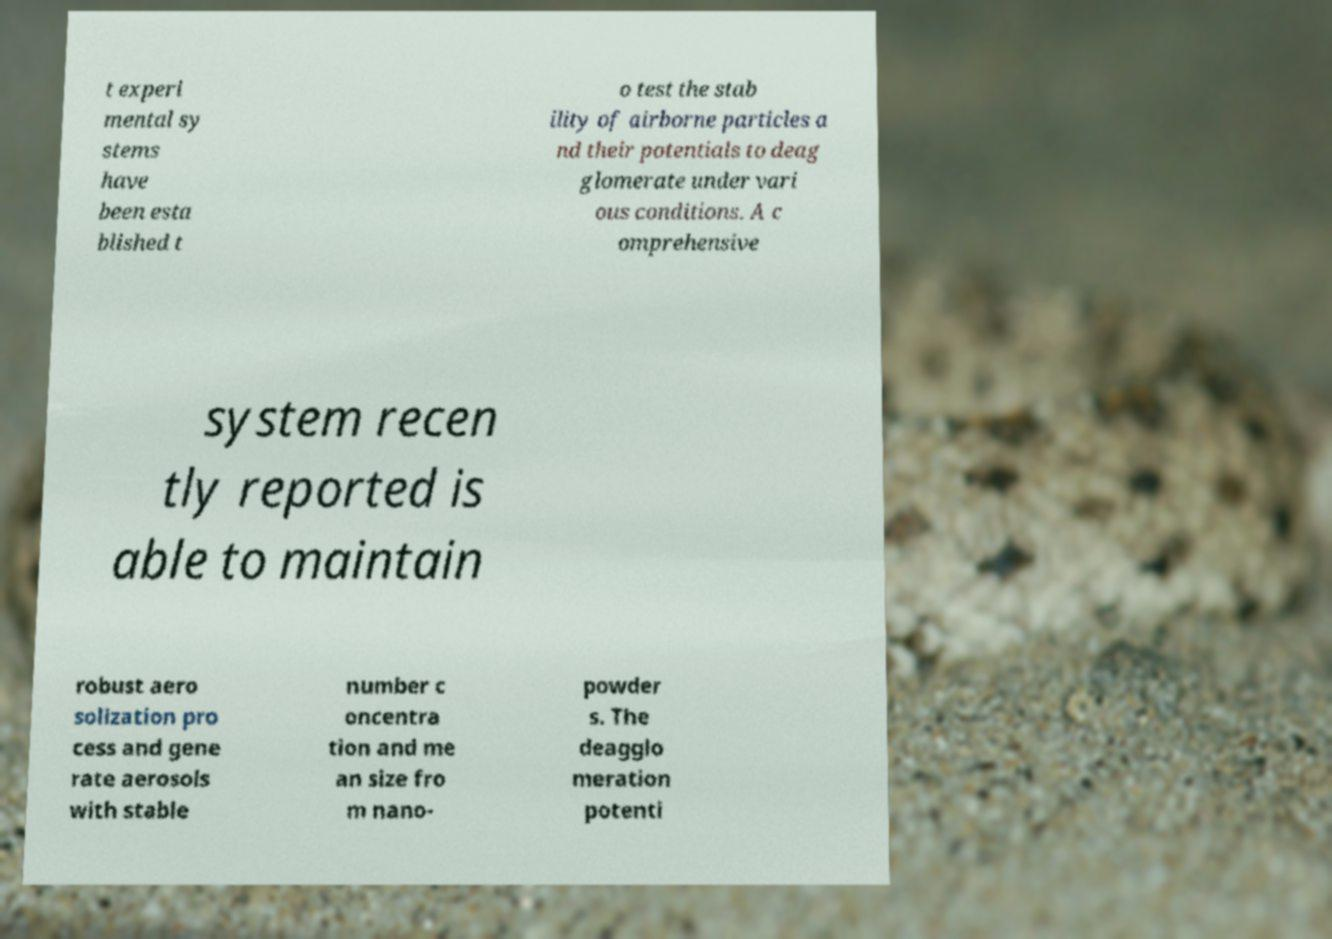Can you read and provide the text displayed in the image?This photo seems to have some interesting text. Can you extract and type it out for me? t experi mental sy stems have been esta blished t o test the stab ility of airborne particles a nd their potentials to deag glomerate under vari ous conditions. A c omprehensive system recen tly reported is able to maintain robust aero solization pro cess and gene rate aerosols with stable number c oncentra tion and me an size fro m nano- powder s. The deagglo meration potenti 